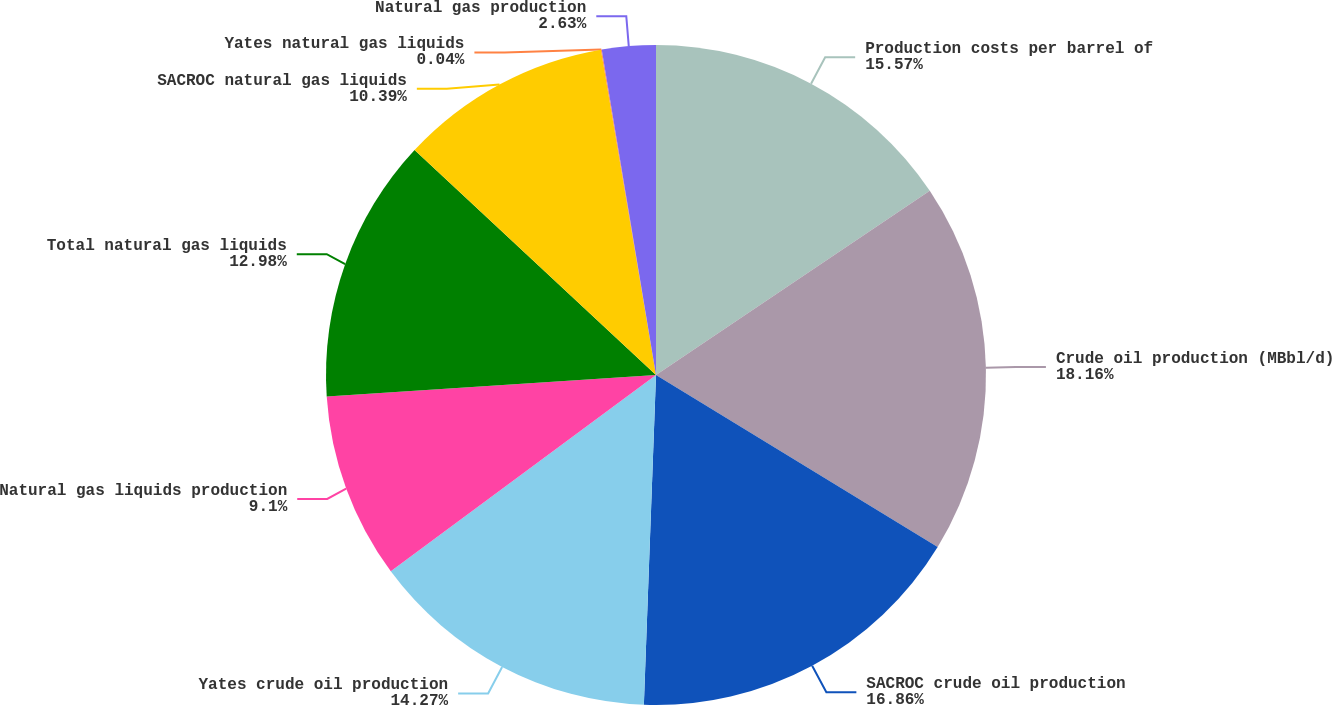<chart> <loc_0><loc_0><loc_500><loc_500><pie_chart><fcel>Production costs per barrel of<fcel>Crude oil production (MBbl/d)<fcel>SACROC crude oil production<fcel>Yates crude oil production<fcel>Natural gas liquids production<fcel>Total natural gas liquids<fcel>SACROC natural gas liquids<fcel>Yates natural gas liquids<fcel>Natural gas production<nl><fcel>15.57%<fcel>18.15%<fcel>16.86%<fcel>14.27%<fcel>9.1%<fcel>12.98%<fcel>10.39%<fcel>0.04%<fcel>2.63%<nl></chart> 